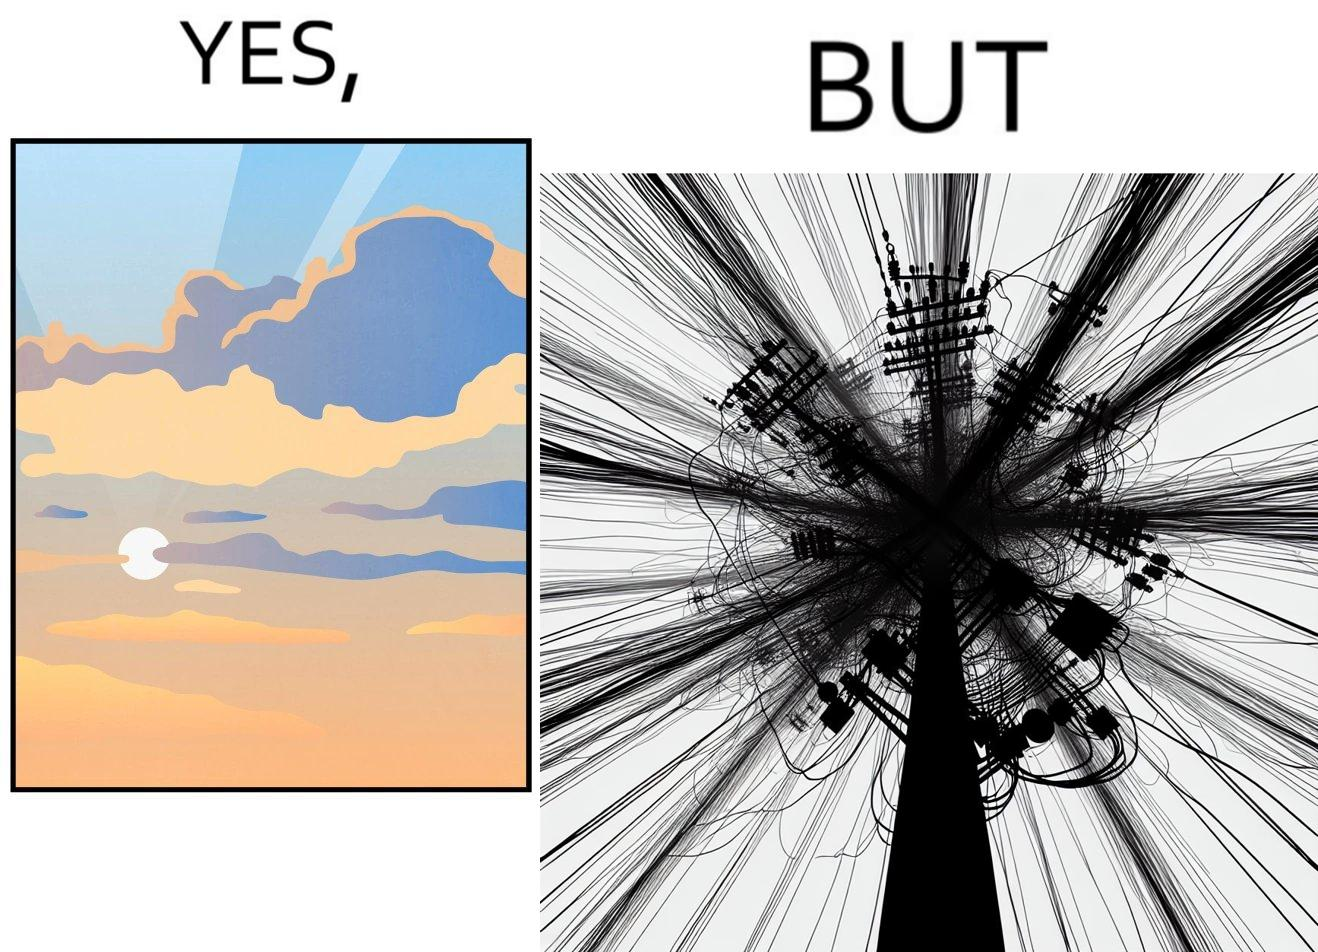Is this image satirical or non-satirical? Yes, this image is satirical. 